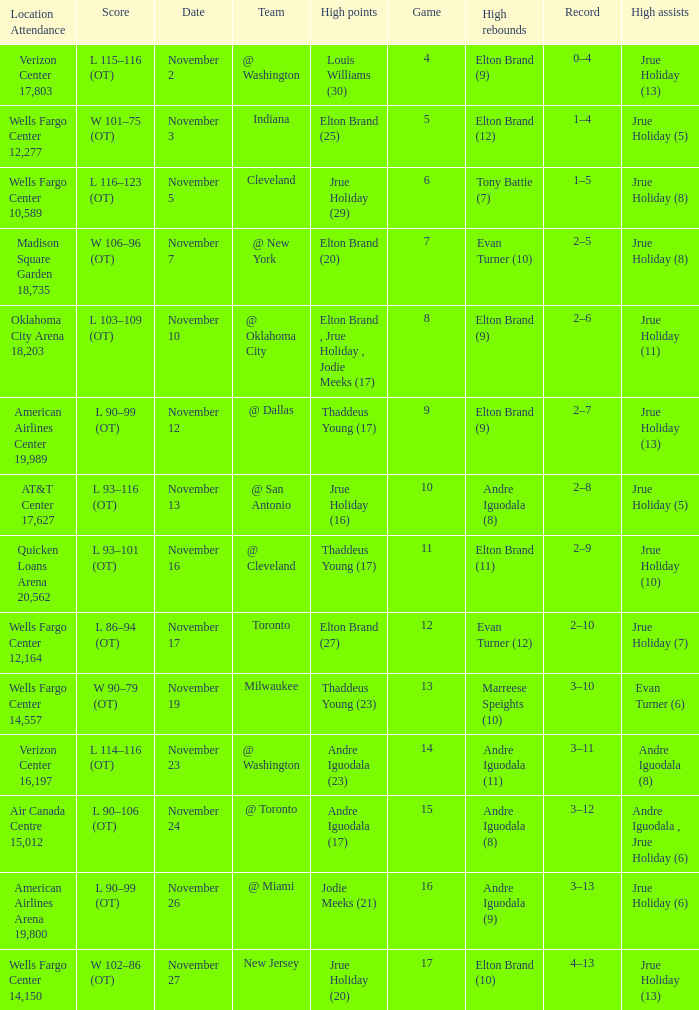How many games are shown for the game where andre iguodala (9) had the high rebounds? 1.0. 